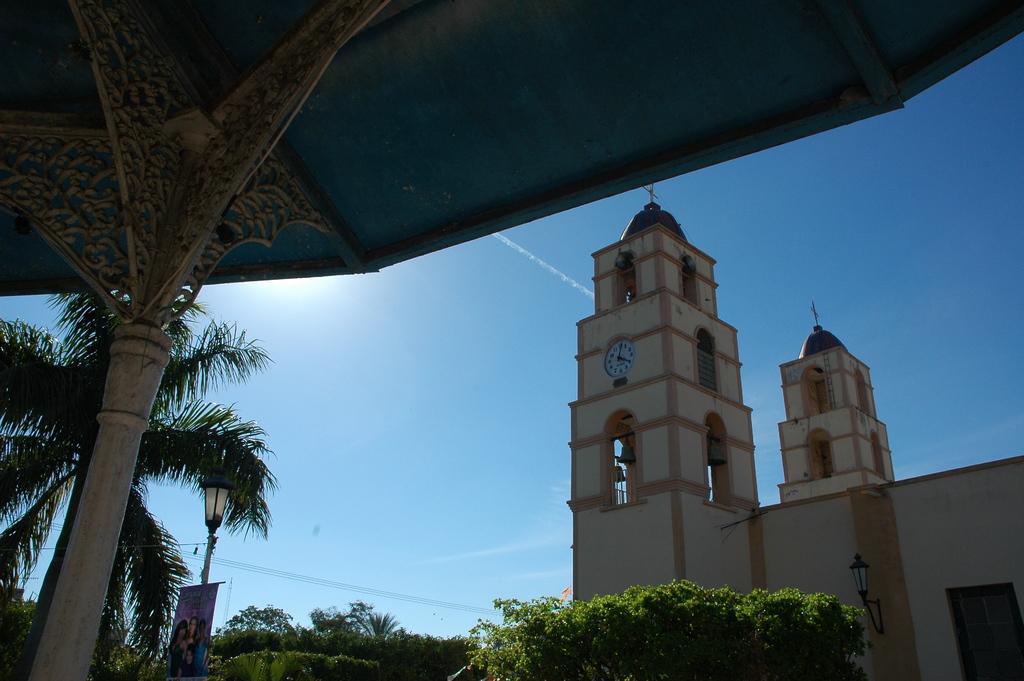How would you summarize this image in a sentence or two? In this image we can see a tower with a clock. We can also see a roof with a pole. On the backside we can see some trees, wires, a street light with a banner and the sky which looks cloudy. 